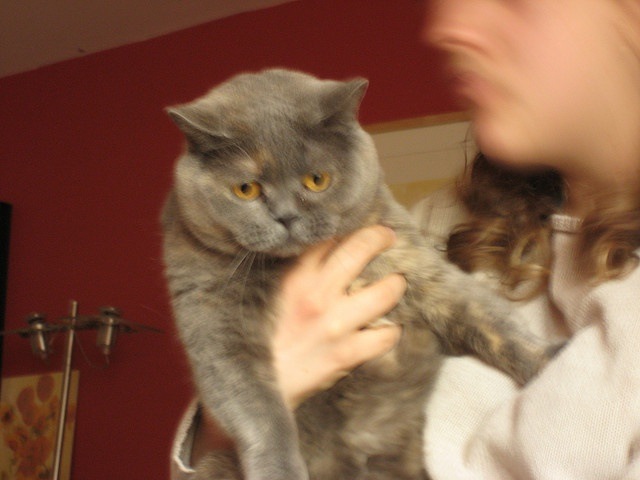Describe the objects in this image and their specific colors. I can see cat in maroon, gray, and tan tones and people in maroon, beige, and tan tones in this image. 